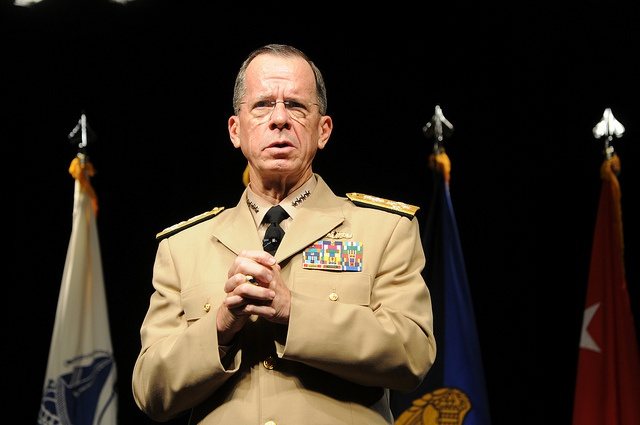Describe the objects in this image and their specific colors. I can see people in black and tan tones and tie in black and gray tones in this image. 